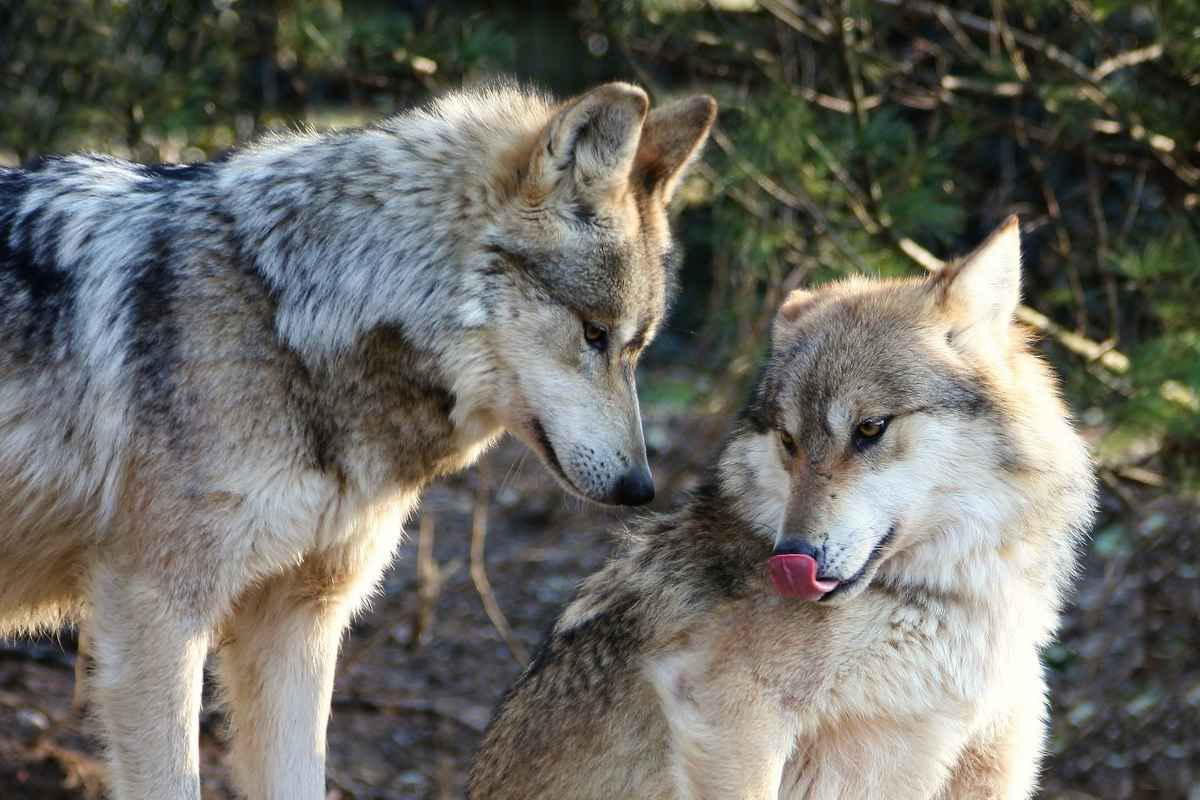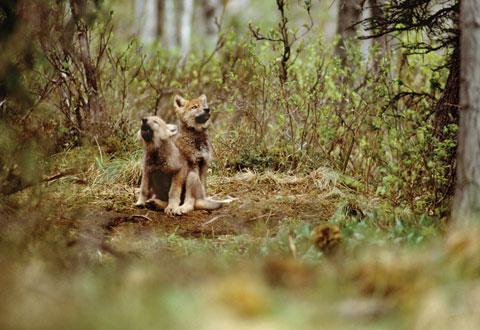The first image is the image on the left, the second image is the image on the right. Given the left and right images, does the statement "The right image contains three wolves in the snow." hold true? Answer yes or no. No. The first image is the image on the left, the second image is the image on the right. For the images shown, is this caption "The animals in the image on the right are in the snow." true? Answer yes or no. No. 